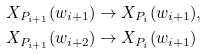<formula> <loc_0><loc_0><loc_500><loc_500>X _ { P _ { i + 1 } } ( w _ { i + 1 } ) & \rightarrow X _ { P _ { i } } ( w _ { i + 1 } ) , \\ X _ { P _ { i + 1 } } ( w _ { i + 2 } ) & \rightarrow X _ { P _ { i } } ( w _ { i + 1 } )</formula> 